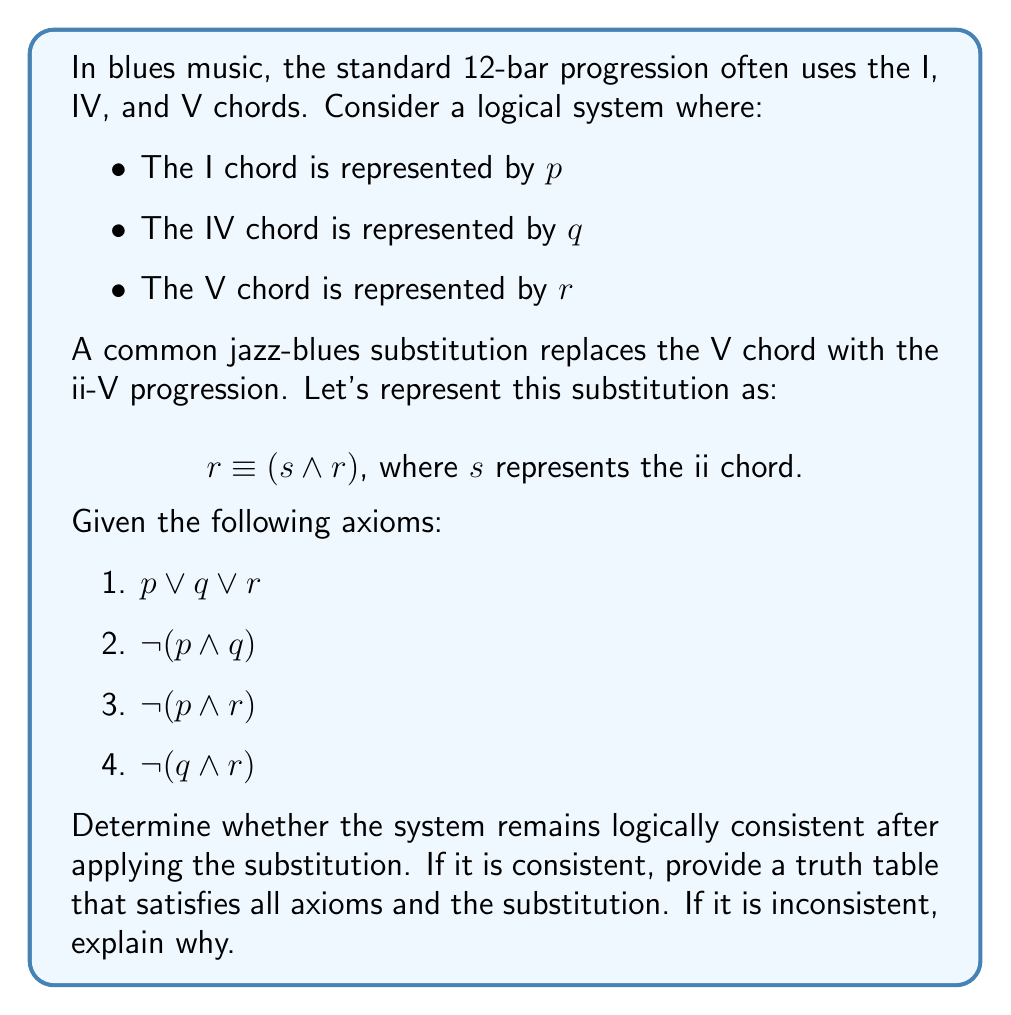Can you solve this math problem? To evaluate the logical consistency of this system after applying the chord substitution, we need to:

1. Apply the substitution to the original axioms
2. Create a truth table for the modified system
3. Check if there exists at least one row in the truth table where all axioms are true

Let's start by applying the substitution $r \equiv (s \land r)$ to the original axioms:

1. $p \lor q \lor (s \land r)$
2. $\lnot(p \land q)$
3. $\lnot(p \land (s \land r))$
4. $\lnot(q \land (s \land r))$

Now, let's create a truth table for this system:

$$
\begin{array}{|c|c|c|c|c|c|c|c|}
\hline
p & q & s & r & p \lor q \lor (s \land r) & \lnot(p \land q) & \lnot(p \land (s \land r)) & \lnot(q \land (s \land r)) \\
\hline
T & T & T & T & T & F & F & F \\
T & T & T & F & T & F & T & T \\
T & T & F & T & T & F & F & F \\
T & T & F & F & T & F & T & T \\
T & F & T & T & T & T & F & T \\
T & F & T & F & T & T & T & T \\
T & F & F & T & T & T & F & T \\
T & F & F & F & T & T & T & T \\
F & T & T & T & T & T & T & F \\
F & T & T & F & T & T & T & T \\
F & T & F & T & T & T & T & F \\
F & T & F & F & T & T & T & T \\
F & F & T & T & T & T & T & T \\
F & F & T & F & F & T & T & T \\
F & F & F & T & T & T & T & T \\
F & F & F & F & F & T & T & T \\
\hline
\end{array}
$$

Examining the truth table, we can see that there are rows where all axioms are true simultaneously. For example, the row where $p = F$, $q = F$, $s = T$, and $r = T$ satisfies all four axioms. This means the system remains logically consistent after applying the substitution.

The existence of at least one row where all axioms are true proves that the system is logically consistent. In this case, we have multiple such rows, which further reinforces the consistency of the system.

From a musical perspective, this logical consistency suggests that the ii-V substitution for the V chord in a jazz-blues progression maintains the harmonic integrity of the original progression while adding harmonic complexity.
Answer: The system remains logically consistent after applying the substitution. A truth table satisfying all axioms and the substitution is provided in the explanation, with multiple rows where all axioms are true simultaneously, such as when $p = F$, $q = F$, $s = T$, and $r = T$. 